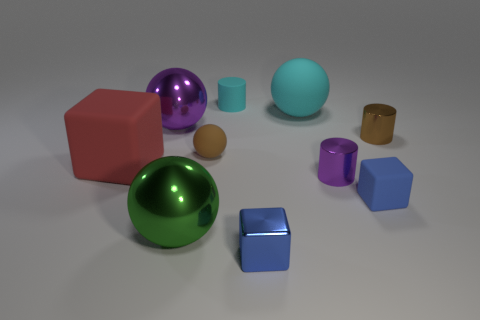Subtract all cylinders. How many objects are left? 7 Add 6 big metal spheres. How many big metal spheres are left? 8 Add 1 tiny blue metallic blocks. How many tiny blue metallic blocks exist? 2 Subtract 1 green balls. How many objects are left? 9 Subtract all large red cubes. Subtract all cylinders. How many objects are left? 6 